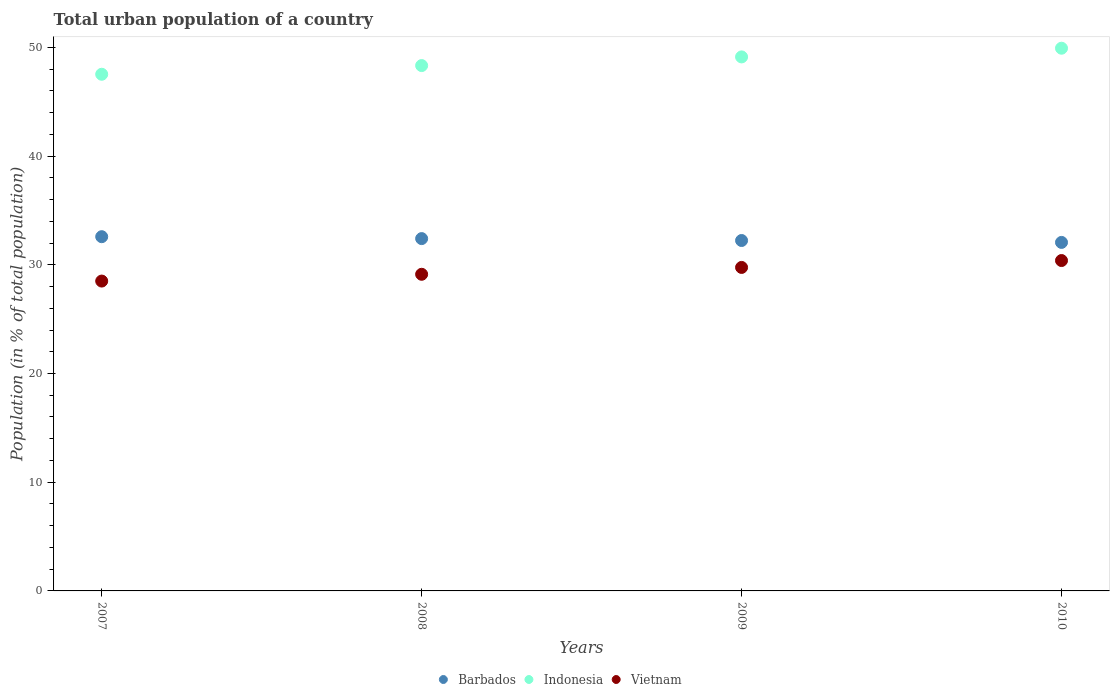How many different coloured dotlines are there?
Make the answer very short. 3. What is the urban population in Barbados in 2010?
Provide a short and direct response. 32.06. Across all years, what is the maximum urban population in Indonesia?
Your answer should be very brief. 49.92. Across all years, what is the minimum urban population in Vietnam?
Ensure brevity in your answer.  28.5. What is the total urban population in Barbados in the graph?
Make the answer very short. 129.29. What is the difference between the urban population in Vietnam in 2009 and that in 2010?
Give a very brief answer. -0.63. What is the difference between the urban population in Indonesia in 2009 and the urban population in Barbados in 2008?
Make the answer very short. 16.71. What is the average urban population in Indonesia per year?
Offer a terse response. 48.73. In the year 2008, what is the difference between the urban population in Vietnam and urban population in Indonesia?
Provide a succinct answer. -19.2. In how many years, is the urban population in Indonesia greater than 2 %?
Give a very brief answer. 4. What is the ratio of the urban population in Barbados in 2007 to that in 2010?
Provide a short and direct response. 1.02. Is the urban population in Vietnam in 2007 less than that in 2009?
Ensure brevity in your answer.  Yes. What is the difference between the highest and the second highest urban population in Vietnam?
Ensure brevity in your answer.  0.63. What is the difference between the highest and the lowest urban population in Barbados?
Make the answer very short. 0.53. In how many years, is the urban population in Indonesia greater than the average urban population in Indonesia taken over all years?
Keep it short and to the point. 2. Is it the case that in every year, the sum of the urban population in Vietnam and urban population in Indonesia  is greater than the urban population in Barbados?
Provide a short and direct response. Yes. Does the urban population in Indonesia monotonically increase over the years?
Ensure brevity in your answer.  Yes. Is the urban population in Vietnam strictly greater than the urban population in Indonesia over the years?
Make the answer very short. No. Is the urban population in Indonesia strictly less than the urban population in Vietnam over the years?
Your response must be concise. No. Are the values on the major ticks of Y-axis written in scientific E-notation?
Make the answer very short. No. Does the graph contain any zero values?
Your response must be concise. No. Does the graph contain grids?
Ensure brevity in your answer.  No. What is the title of the graph?
Ensure brevity in your answer.  Total urban population of a country. What is the label or title of the Y-axis?
Offer a very short reply. Population (in % of total population). What is the Population (in % of total population) of Barbados in 2007?
Offer a very short reply. 32.59. What is the Population (in % of total population) in Indonesia in 2007?
Provide a short and direct response. 47.53. What is the Population (in % of total population) of Vietnam in 2007?
Ensure brevity in your answer.  28.5. What is the Population (in % of total population) in Barbados in 2008?
Keep it short and to the point. 32.41. What is the Population (in % of total population) in Indonesia in 2008?
Offer a very short reply. 48.33. What is the Population (in % of total population) in Vietnam in 2008?
Keep it short and to the point. 29.13. What is the Population (in % of total population) in Barbados in 2009?
Keep it short and to the point. 32.23. What is the Population (in % of total population) of Indonesia in 2009?
Your response must be concise. 49.12. What is the Population (in % of total population) of Vietnam in 2009?
Offer a very short reply. 29.76. What is the Population (in % of total population) of Barbados in 2010?
Offer a very short reply. 32.06. What is the Population (in % of total population) of Indonesia in 2010?
Provide a short and direct response. 49.92. What is the Population (in % of total population) of Vietnam in 2010?
Keep it short and to the point. 30.39. Across all years, what is the maximum Population (in % of total population) of Barbados?
Make the answer very short. 32.59. Across all years, what is the maximum Population (in % of total population) of Indonesia?
Offer a terse response. 49.92. Across all years, what is the maximum Population (in % of total population) of Vietnam?
Make the answer very short. 30.39. Across all years, what is the minimum Population (in % of total population) of Barbados?
Give a very brief answer. 32.06. Across all years, what is the minimum Population (in % of total population) in Indonesia?
Ensure brevity in your answer.  47.53. Across all years, what is the minimum Population (in % of total population) of Vietnam?
Provide a succinct answer. 28.5. What is the total Population (in % of total population) in Barbados in the graph?
Your response must be concise. 129.29. What is the total Population (in % of total population) in Indonesia in the graph?
Offer a terse response. 194.9. What is the total Population (in % of total population) of Vietnam in the graph?
Your answer should be compact. 117.78. What is the difference between the Population (in % of total population) of Barbados in 2007 and that in 2008?
Make the answer very short. 0.18. What is the difference between the Population (in % of total population) of Indonesia in 2007 and that in 2008?
Offer a terse response. -0.8. What is the difference between the Population (in % of total population) in Vietnam in 2007 and that in 2008?
Your answer should be compact. -0.62. What is the difference between the Population (in % of total population) in Barbados in 2007 and that in 2009?
Your response must be concise. 0.35. What is the difference between the Population (in % of total population) of Indonesia in 2007 and that in 2009?
Provide a succinct answer. -1.6. What is the difference between the Population (in % of total population) of Vietnam in 2007 and that in 2009?
Offer a very short reply. -1.25. What is the difference between the Population (in % of total population) in Barbados in 2007 and that in 2010?
Provide a succinct answer. 0.53. What is the difference between the Population (in % of total population) in Indonesia in 2007 and that in 2010?
Provide a short and direct response. -2.4. What is the difference between the Population (in % of total population) in Vietnam in 2007 and that in 2010?
Your answer should be compact. -1.89. What is the difference between the Population (in % of total population) in Barbados in 2008 and that in 2009?
Your answer should be compact. 0.17. What is the difference between the Population (in % of total population) in Indonesia in 2008 and that in 2009?
Provide a short and direct response. -0.8. What is the difference between the Population (in % of total population) in Vietnam in 2008 and that in 2009?
Ensure brevity in your answer.  -0.63. What is the difference between the Population (in % of total population) of Indonesia in 2008 and that in 2010?
Provide a short and direct response. -1.6. What is the difference between the Population (in % of total population) of Vietnam in 2008 and that in 2010?
Give a very brief answer. -1.26. What is the difference between the Population (in % of total population) of Barbados in 2009 and that in 2010?
Provide a succinct answer. 0.17. What is the difference between the Population (in % of total population) of Indonesia in 2009 and that in 2010?
Give a very brief answer. -0.8. What is the difference between the Population (in % of total population) in Vietnam in 2009 and that in 2010?
Provide a succinct answer. -0.63. What is the difference between the Population (in % of total population) in Barbados in 2007 and the Population (in % of total population) in Indonesia in 2008?
Your answer should be very brief. -15.74. What is the difference between the Population (in % of total population) of Barbados in 2007 and the Population (in % of total population) of Vietnam in 2008?
Your answer should be compact. 3.46. What is the difference between the Population (in % of total population) of Indonesia in 2007 and the Population (in % of total population) of Vietnam in 2008?
Give a very brief answer. 18.4. What is the difference between the Population (in % of total population) of Barbados in 2007 and the Population (in % of total population) of Indonesia in 2009?
Your answer should be very brief. -16.54. What is the difference between the Population (in % of total population) in Barbados in 2007 and the Population (in % of total population) in Vietnam in 2009?
Offer a very short reply. 2.83. What is the difference between the Population (in % of total population) of Indonesia in 2007 and the Population (in % of total population) of Vietnam in 2009?
Provide a short and direct response. 17.77. What is the difference between the Population (in % of total population) in Barbados in 2007 and the Population (in % of total population) in Indonesia in 2010?
Give a very brief answer. -17.34. What is the difference between the Population (in % of total population) of Barbados in 2007 and the Population (in % of total population) of Vietnam in 2010?
Your response must be concise. 2.19. What is the difference between the Population (in % of total population) of Indonesia in 2007 and the Population (in % of total population) of Vietnam in 2010?
Offer a very short reply. 17.14. What is the difference between the Population (in % of total population) of Barbados in 2008 and the Population (in % of total population) of Indonesia in 2009?
Make the answer very short. -16.71. What is the difference between the Population (in % of total population) in Barbados in 2008 and the Population (in % of total population) in Vietnam in 2009?
Keep it short and to the point. 2.65. What is the difference between the Population (in % of total population) of Indonesia in 2008 and the Population (in % of total population) of Vietnam in 2009?
Keep it short and to the point. 18.57. What is the difference between the Population (in % of total population) of Barbados in 2008 and the Population (in % of total population) of Indonesia in 2010?
Ensure brevity in your answer.  -17.51. What is the difference between the Population (in % of total population) of Barbados in 2008 and the Population (in % of total population) of Vietnam in 2010?
Your answer should be compact. 2.02. What is the difference between the Population (in % of total population) of Indonesia in 2008 and the Population (in % of total population) of Vietnam in 2010?
Offer a very short reply. 17.93. What is the difference between the Population (in % of total population) of Barbados in 2009 and the Population (in % of total population) of Indonesia in 2010?
Keep it short and to the point. -17.69. What is the difference between the Population (in % of total population) of Barbados in 2009 and the Population (in % of total population) of Vietnam in 2010?
Offer a terse response. 1.84. What is the difference between the Population (in % of total population) in Indonesia in 2009 and the Population (in % of total population) in Vietnam in 2010?
Make the answer very short. 18.73. What is the average Population (in % of total population) in Barbados per year?
Your answer should be very brief. 32.32. What is the average Population (in % of total population) in Indonesia per year?
Your answer should be compact. 48.73. What is the average Population (in % of total population) in Vietnam per year?
Your answer should be very brief. 29.45. In the year 2007, what is the difference between the Population (in % of total population) in Barbados and Population (in % of total population) in Indonesia?
Your answer should be compact. -14.94. In the year 2007, what is the difference between the Population (in % of total population) of Barbados and Population (in % of total population) of Vietnam?
Keep it short and to the point. 4.08. In the year 2007, what is the difference between the Population (in % of total population) of Indonesia and Population (in % of total population) of Vietnam?
Ensure brevity in your answer.  19.02. In the year 2008, what is the difference between the Population (in % of total population) of Barbados and Population (in % of total population) of Indonesia?
Give a very brief answer. -15.92. In the year 2008, what is the difference between the Population (in % of total population) of Barbados and Population (in % of total population) of Vietnam?
Provide a succinct answer. 3.28. In the year 2008, what is the difference between the Population (in % of total population) in Indonesia and Population (in % of total population) in Vietnam?
Your answer should be compact. 19.2. In the year 2009, what is the difference between the Population (in % of total population) of Barbados and Population (in % of total population) of Indonesia?
Provide a succinct answer. -16.89. In the year 2009, what is the difference between the Population (in % of total population) of Barbados and Population (in % of total population) of Vietnam?
Your answer should be very brief. 2.48. In the year 2009, what is the difference between the Population (in % of total population) of Indonesia and Population (in % of total population) of Vietnam?
Your answer should be compact. 19.37. In the year 2010, what is the difference between the Population (in % of total population) in Barbados and Population (in % of total population) in Indonesia?
Your answer should be compact. -17.86. In the year 2010, what is the difference between the Population (in % of total population) in Barbados and Population (in % of total population) in Vietnam?
Your answer should be compact. 1.67. In the year 2010, what is the difference between the Population (in % of total population) in Indonesia and Population (in % of total population) in Vietnam?
Offer a very short reply. 19.53. What is the ratio of the Population (in % of total population) of Barbados in 2007 to that in 2008?
Your answer should be compact. 1.01. What is the ratio of the Population (in % of total population) of Indonesia in 2007 to that in 2008?
Make the answer very short. 0.98. What is the ratio of the Population (in % of total population) of Vietnam in 2007 to that in 2008?
Offer a terse response. 0.98. What is the ratio of the Population (in % of total population) of Barbados in 2007 to that in 2009?
Your answer should be very brief. 1.01. What is the ratio of the Population (in % of total population) in Indonesia in 2007 to that in 2009?
Offer a terse response. 0.97. What is the ratio of the Population (in % of total population) of Vietnam in 2007 to that in 2009?
Your answer should be compact. 0.96. What is the ratio of the Population (in % of total population) of Barbados in 2007 to that in 2010?
Offer a terse response. 1.02. What is the ratio of the Population (in % of total population) in Vietnam in 2007 to that in 2010?
Keep it short and to the point. 0.94. What is the ratio of the Population (in % of total population) of Barbados in 2008 to that in 2009?
Provide a succinct answer. 1.01. What is the ratio of the Population (in % of total population) in Indonesia in 2008 to that in 2009?
Provide a short and direct response. 0.98. What is the ratio of the Population (in % of total population) in Vietnam in 2008 to that in 2009?
Your answer should be compact. 0.98. What is the ratio of the Population (in % of total population) of Barbados in 2008 to that in 2010?
Offer a very short reply. 1.01. What is the ratio of the Population (in % of total population) in Vietnam in 2008 to that in 2010?
Ensure brevity in your answer.  0.96. What is the ratio of the Population (in % of total population) of Vietnam in 2009 to that in 2010?
Ensure brevity in your answer.  0.98. What is the difference between the highest and the second highest Population (in % of total population) in Barbados?
Your response must be concise. 0.18. What is the difference between the highest and the second highest Population (in % of total population) of Vietnam?
Keep it short and to the point. 0.63. What is the difference between the highest and the lowest Population (in % of total population) in Barbados?
Offer a very short reply. 0.53. What is the difference between the highest and the lowest Population (in % of total population) of Indonesia?
Your answer should be compact. 2.4. What is the difference between the highest and the lowest Population (in % of total population) in Vietnam?
Your answer should be very brief. 1.89. 